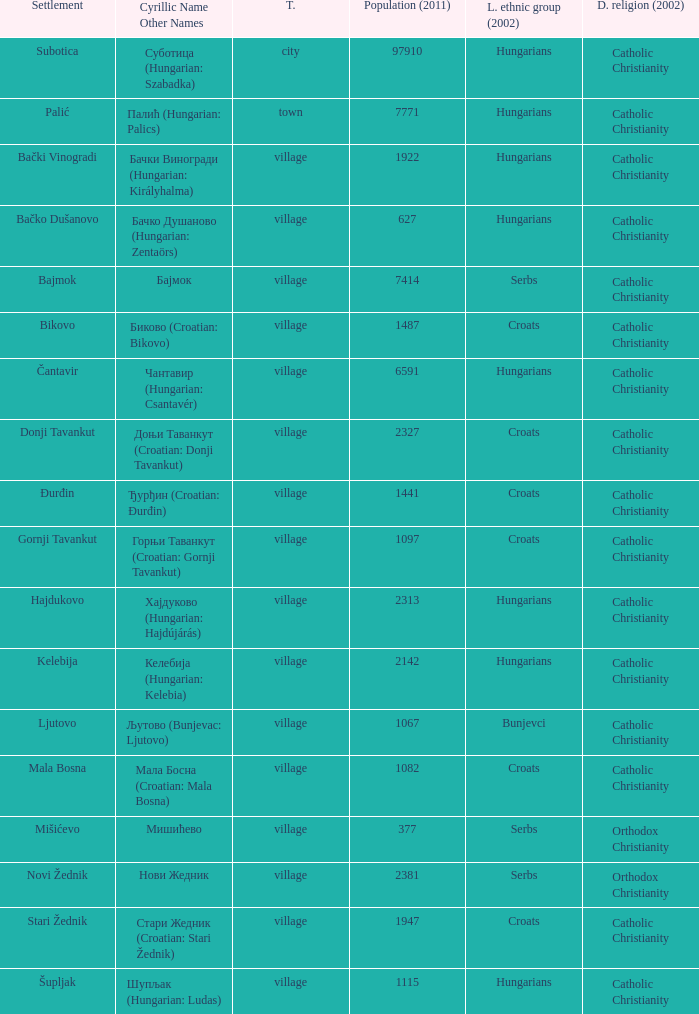What is the population in стари жедник (croatian: stari žednik)? 1947.0. 